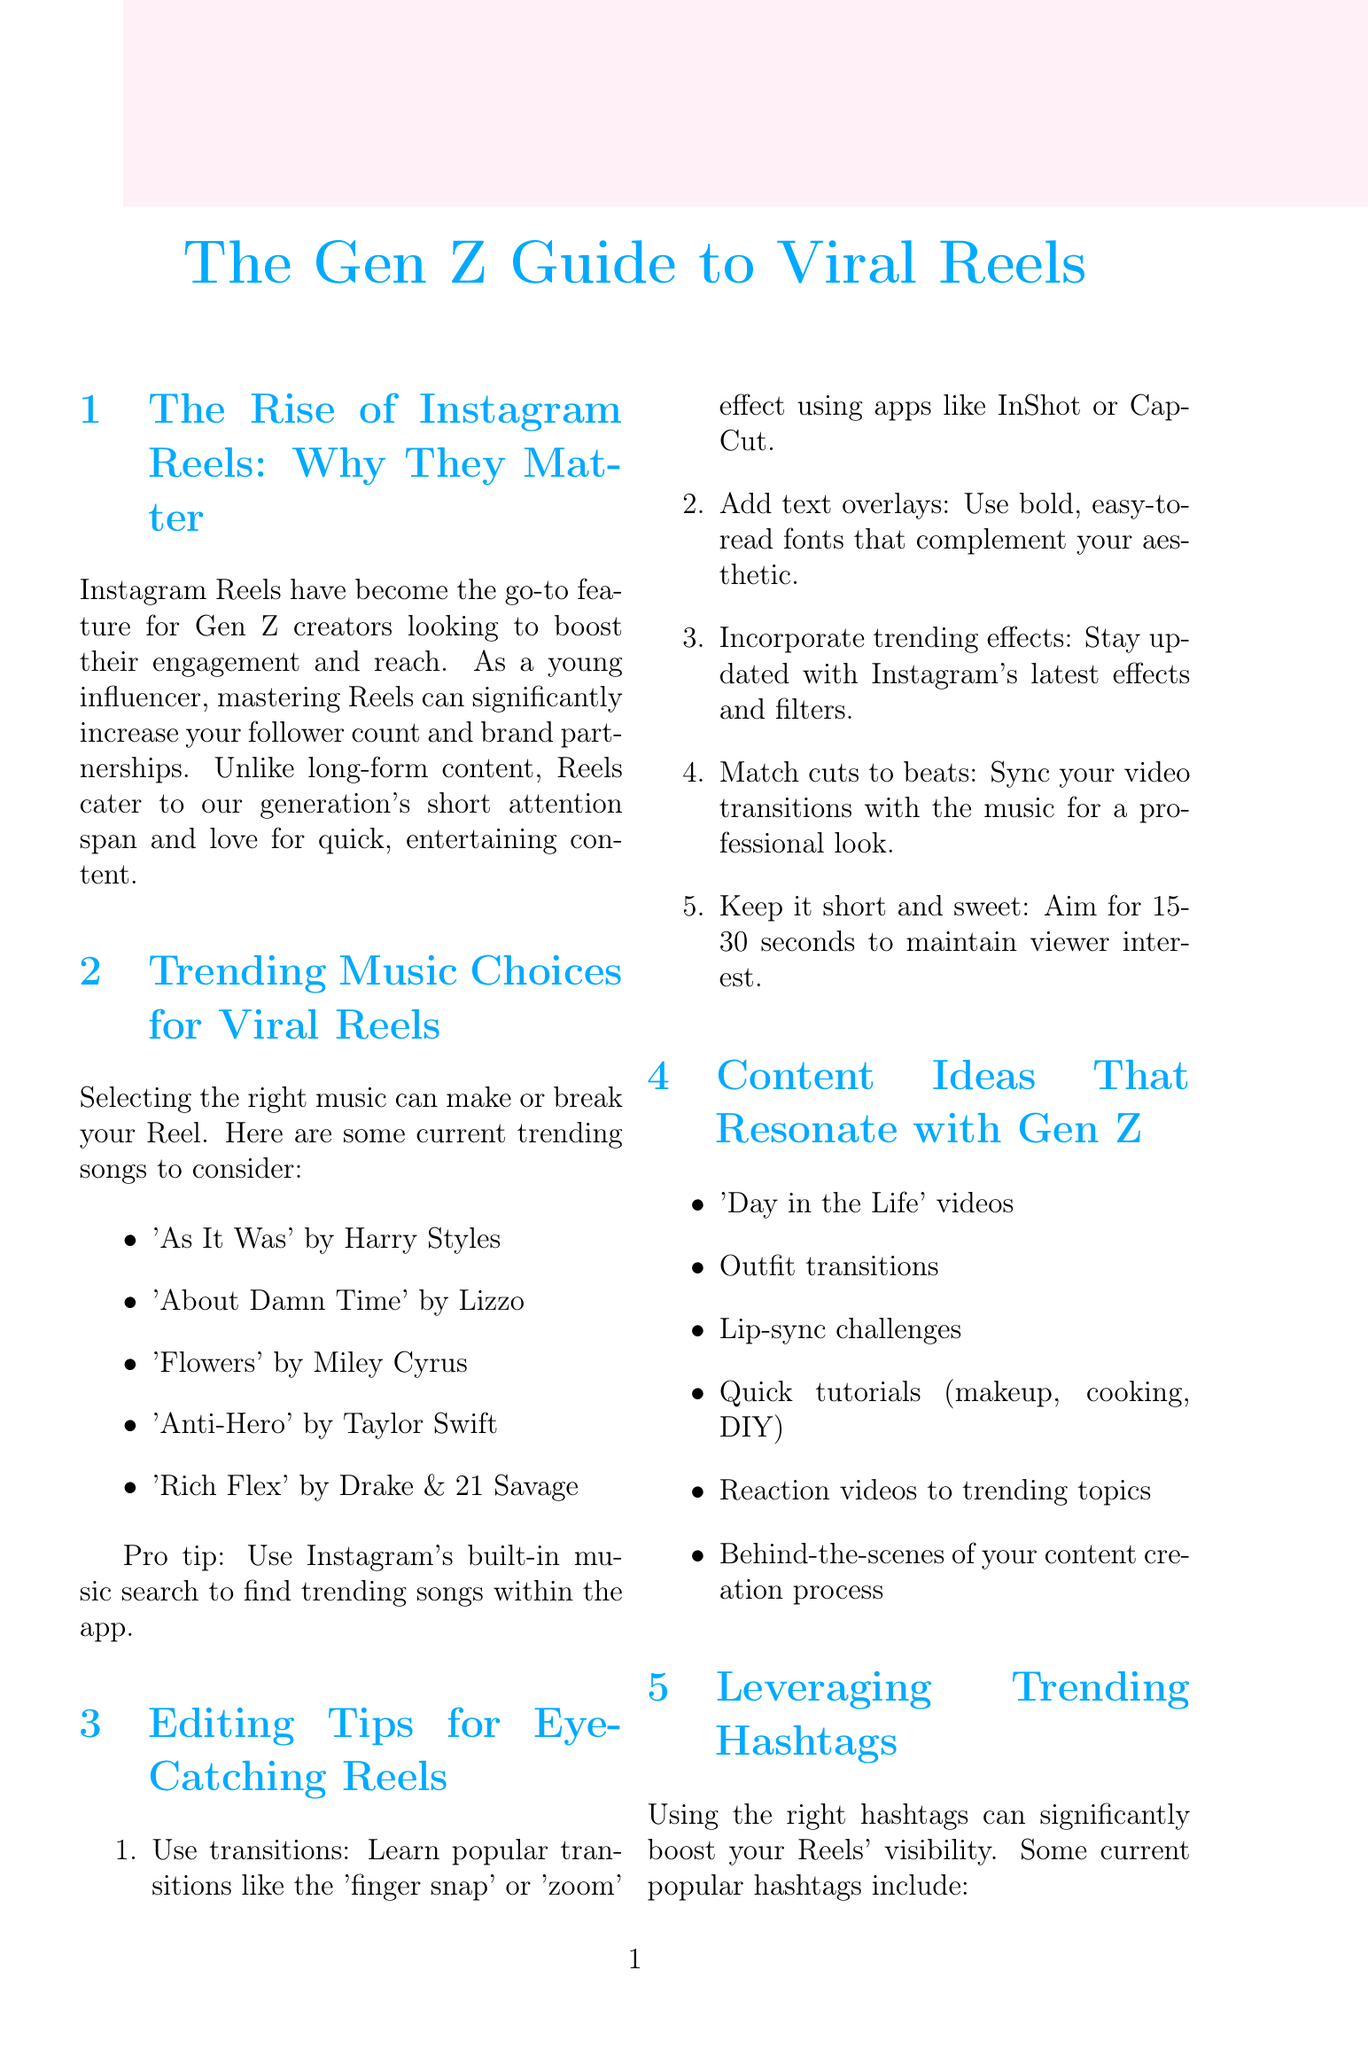What is the main purpose of using Instagram Reels? The main purpose of using Instagram Reels is to boost engagement and reach for Gen Z creators.
Answer: Boost engagement and reach Which song by Lizzo is listed as trending? The specific song by Lizzo that is trending is mentioned in the music section of the document.
Answer: About Damn Time What is a pro tip for selecting music for Reels? The document provides a specific tip regarding how to find trending songs on Instagram.
Answer: Use Instagram's built-in music search What is the recommended duration for Reels? The document states an optimal time frame for maintaining viewer interest in Reels.
Answer: 15-30 seconds What are two content ideas that resonate with Gen Z? The document lists content ideas relevant to Gen Z influencers.
Answer: Day in the Life, Outfit transitions How should you mix your hashtags for better visibility? The document suggests a strategy for combining different types of hashtags in your Reels.
Answer: Mix trending hashtags with niche-specific ones What’s a key editing tip for enhancing video transitions? A specific technique for improving transitions in Reels is discussed in the editing tips section.
Answer: Match cuts to beats Which feature can be used for collaborations? The document mentions a specific Instagram feature that facilitates partnerships.
Answer: Collab feature 